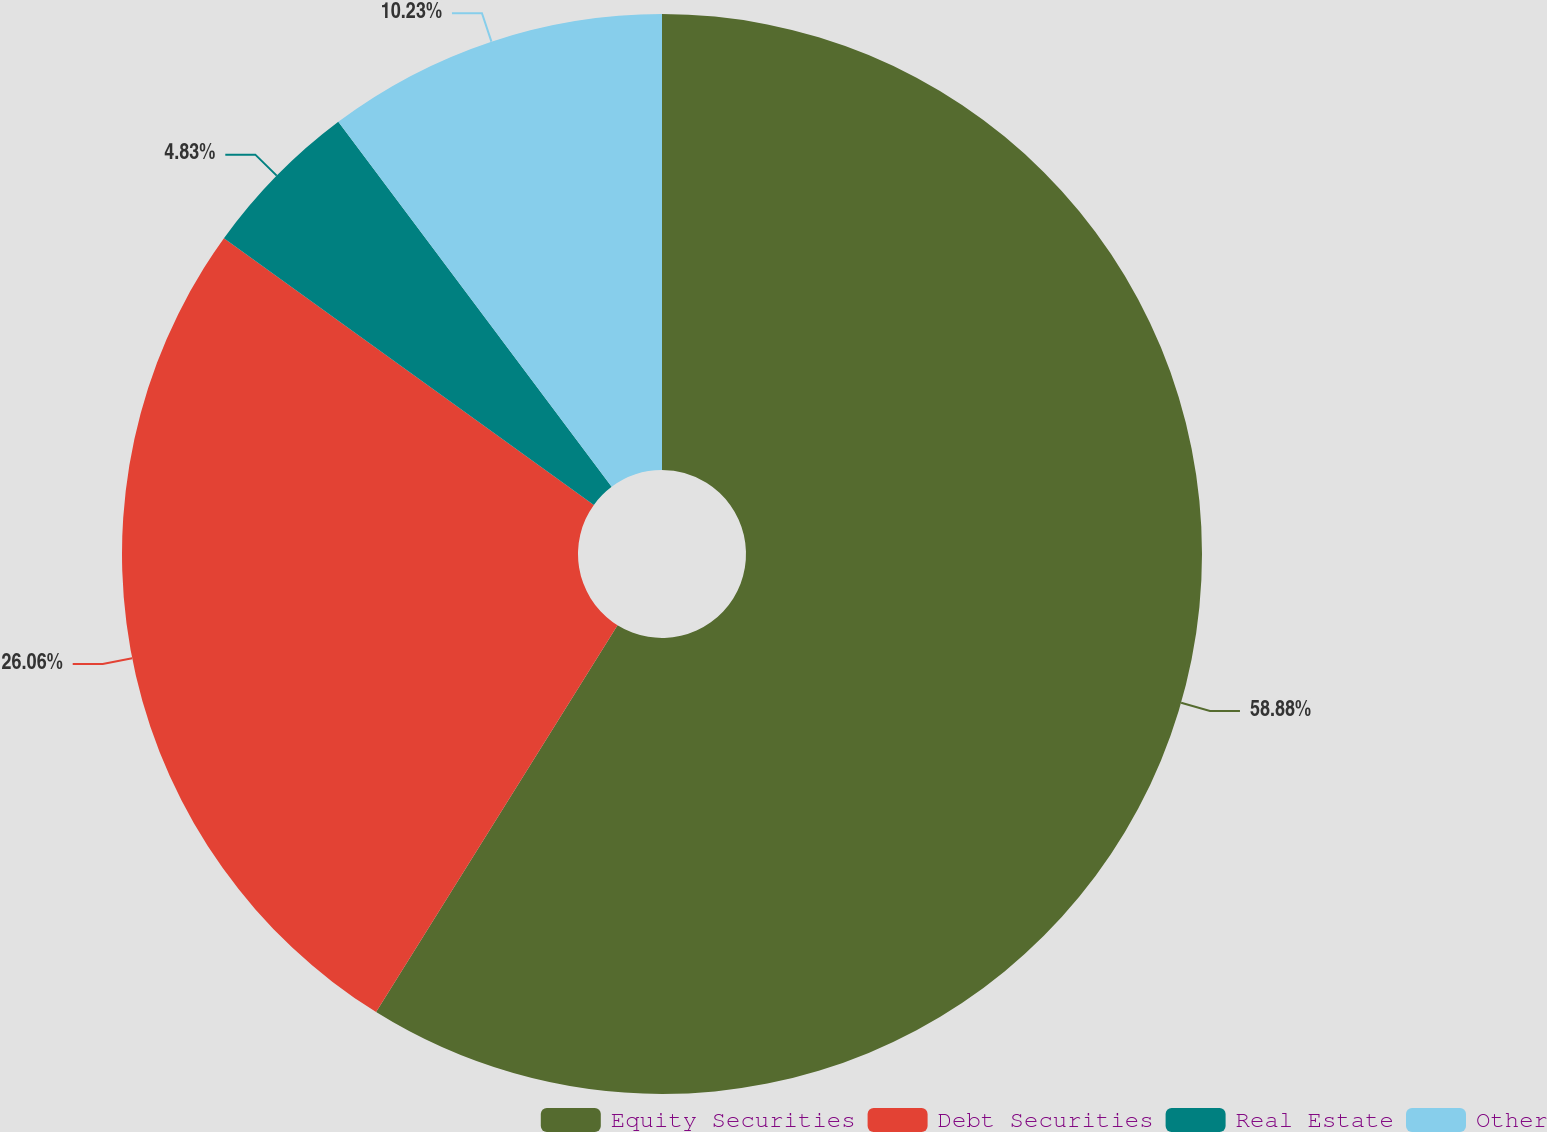Convert chart. <chart><loc_0><loc_0><loc_500><loc_500><pie_chart><fcel>Equity Securities<fcel>Debt Securities<fcel>Real Estate<fcel>Other<nl><fcel>58.88%<fcel>26.06%<fcel>4.83%<fcel>10.23%<nl></chart> 